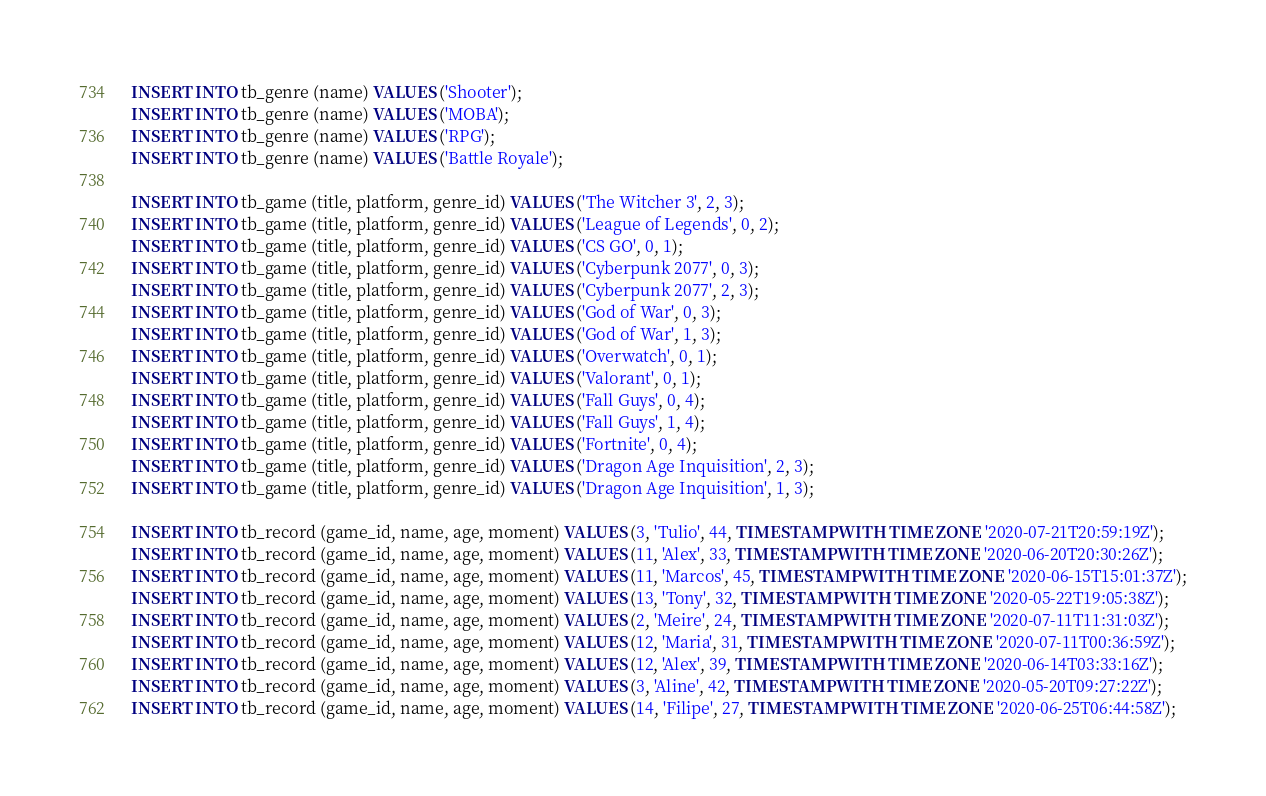Convert code to text. <code><loc_0><loc_0><loc_500><loc_500><_SQL_>INSERT INTO tb_genre (name) VALUES ('Shooter');
INSERT INTO tb_genre (name) VALUES ('MOBA');
INSERT INTO tb_genre (name) VALUES ('RPG');
INSERT INTO tb_genre (name) VALUES ('Battle Royale');

INSERT INTO tb_game (title, platform, genre_id) VALUES ('The Witcher 3', 2, 3);
INSERT INTO tb_game (title, platform, genre_id) VALUES ('League of Legends', 0, 2);
INSERT INTO tb_game (title, platform, genre_id) VALUES ('CS GO', 0, 1);
INSERT INTO tb_game (title, platform, genre_id) VALUES ('Cyberpunk 2077', 0, 3);
INSERT INTO tb_game (title, platform, genre_id) VALUES ('Cyberpunk 2077', 2, 3);
INSERT INTO tb_game (title, platform, genre_id) VALUES ('God of War', 0, 3);
INSERT INTO tb_game (title, platform, genre_id) VALUES ('God of War', 1, 3);
INSERT INTO tb_game (title, platform, genre_id) VALUES ('Overwatch', 0, 1);
INSERT INTO tb_game (title, platform, genre_id) VALUES ('Valorant', 0, 1);
INSERT INTO tb_game (title, platform, genre_id) VALUES ('Fall Guys', 0, 4);
INSERT INTO tb_game (title, platform, genre_id) VALUES ('Fall Guys', 1, 4);
INSERT INTO tb_game (title, platform, genre_id) VALUES ('Fortnite', 0, 4);
INSERT INTO tb_game (title, platform, genre_id) VALUES ('Dragon Age Inquisition', 2, 3);
INSERT INTO tb_game (title, platform, genre_id) VALUES ('Dragon Age Inquisition', 1, 3);

INSERT INTO tb_record (game_id, name, age, moment) VALUES (3, 'Tulio', 44, TIMESTAMP WITH TIME ZONE '2020-07-21T20:59:19Z');
INSERT INTO tb_record (game_id, name, age, moment) VALUES (11, 'Alex', 33, TIMESTAMP WITH TIME ZONE '2020-06-20T20:30:26Z');
INSERT INTO tb_record (game_id, name, age, moment) VALUES (11, 'Marcos', 45, TIMESTAMP WITH TIME ZONE '2020-06-15T15:01:37Z');
INSERT INTO tb_record (game_id, name, age, moment) VALUES (13, 'Tony', 32, TIMESTAMP WITH TIME ZONE '2020-05-22T19:05:38Z');
INSERT INTO tb_record (game_id, name, age, moment) VALUES (2, 'Meire', 24, TIMESTAMP WITH TIME ZONE '2020-07-11T11:31:03Z');
INSERT INTO tb_record (game_id, name, age, moment) VALUES (12, 'Maria', 31, TIMESTAMP WITH TIME ZONE '2020-07-11T00:36:59Z');
INSERT INTO tb_record (game_id, name, age, moment) VALUES (12, 'Alex', 39, TIMESTAMP WITH TIME ZONE '2020-06-14T03:33:16Z');
INSERT INTO tb_record (game_id, name, age, moment) VALUES (3, 'Aline', 42, TIMESTAMP WITH TIME ZONE '2020-05-20T09:27:22Z');
INSERT INTO tb_record (game_id, name, age, moment) VALUES (14, 'Filipe', 27, TIMESTAMP WITH TIME ZONE '2020-06-25T06:44:58Z');</code> 